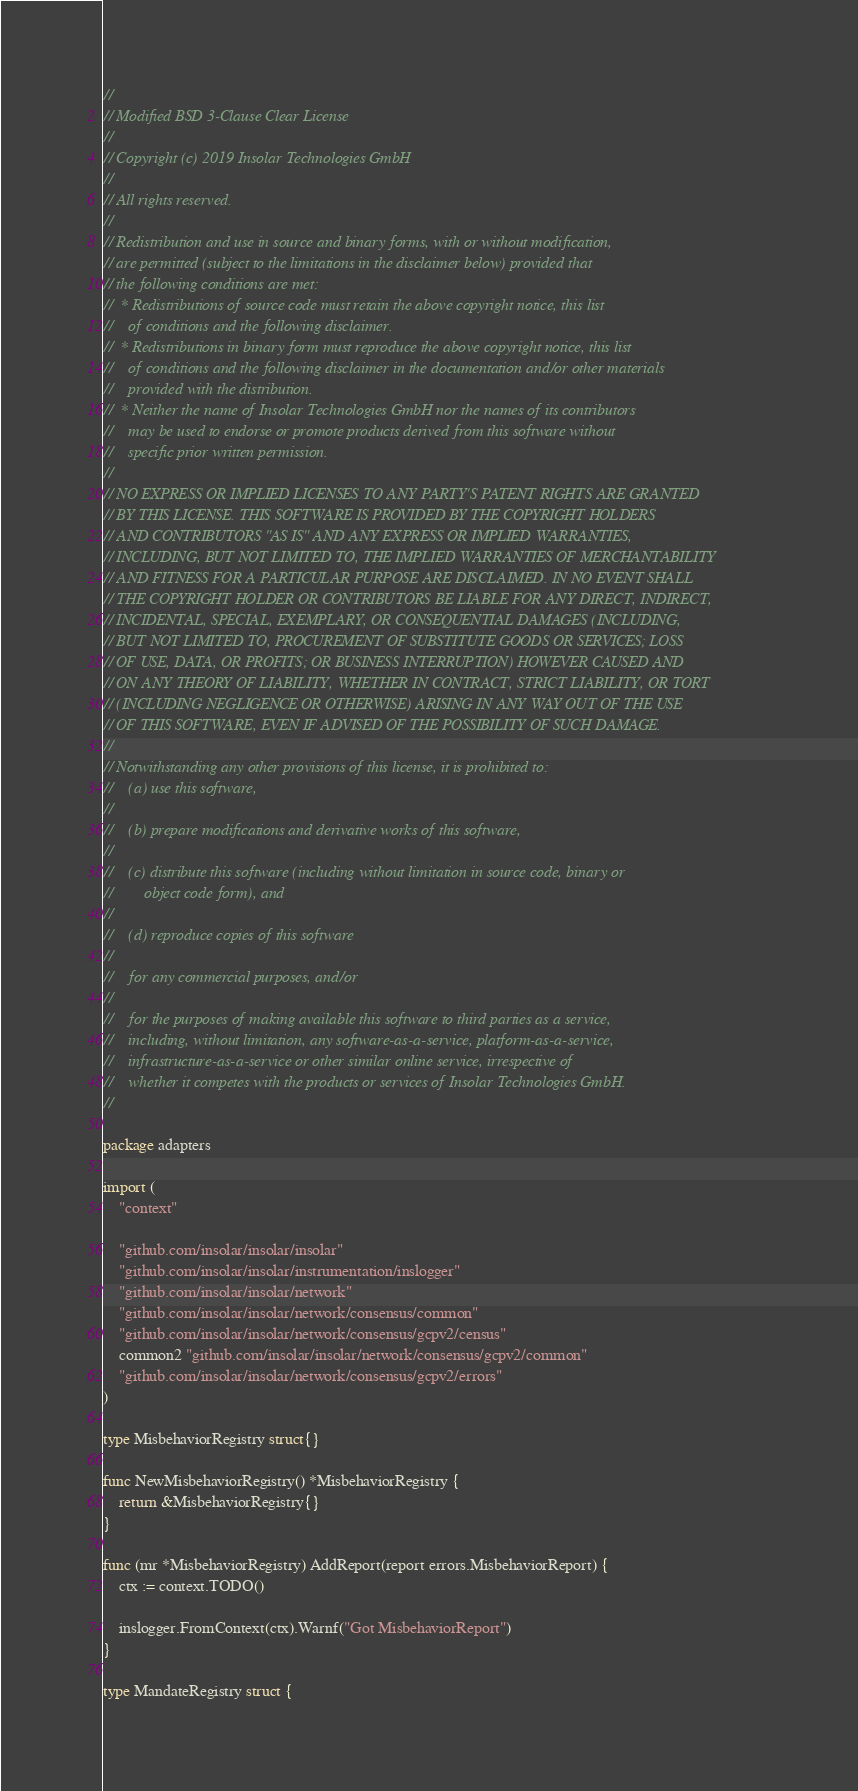Convert code to text. <code><loc_0><loc_0><loc_500><loc_500><_Go_>//
// Modified BSD 3-Clause Clear License
//
// Copyright (c) 2019 Insolar Technologies GmbH
//
// All rights reserved.
//
// Redistribution and use in source and binary forms, with or without modification,
// are permitted (subject to the limitations in the disclaimer below) provided that
// the following conditions are met:
//  * Redistributions of source code must retain the above copyright notice, this list
//    of conditions and the following disclaimer.
//  * Redistributions in binary form must reproduce the above copyright notice, this list
//    of conditions and the following disclaimer in the documentation and/or other materials
//    provided with the distribution.
//  * Neither the name of Insolar Technologies GmbH nor the names of its contributors
//    may be used to endorse or promote products derived from this software without
//    specific prior written permission.
//
// NO EXPRESS OR IMPLIED LICENSES TO ANY PARTY'S PATENT RIGHTS ARE GRANTED
// BY THIS LICENSE. THIS SOFTWARE IS PROVIDED BY THE COPYRIGHT HOLDERS
// AND CONTRIBUTORS "AS IS" AND ANY EXPRESS OR IMPLIED WARRANTIES,
// INCLUDING, BUT NOT LIMITED TO, THE IMPLIED WARRANTIES OF MERCHANTABILITY
// AND FITNESS FOR A PARTICULAR PURPOSE ARE DISCLAIMED. IN NO EVENT SHALL
// THE COPYRIGHT HOLDER OR CONTRIBUTORS BE LIABLE FOR ANY DIRECT, INDIRECT,
// INCIDENTAL, SPECIAL, EXEMPLARY, OR CONSEQUENTIAL DAMAGES (INCLUDING,
// BUT NOT LIMITED TO, PROCUREMENT OF SUBSTITUTE GOODS OR SERVICES; LOSS
// OF USE, DATA, OR PROFITS; OR BUSINESS INTERRUPTION) HOWEVER CAUSED AND
// ON ANY THEORY OF LIABILITY, WHETHER IN CONTRACT, STRICT LIABILITY, OR TORT
// (INCLUDING NEGLIGENCE OR OTHERWISE) ARISING IN ANY WAY OUT OF THE USE
// OF THIS SOFTWARE, EVEN IF ADVISED OF THE POSSIBILITY OF SUCH DAMAGE.
//
// Notwithstanding any other provisions of this license, it is prohibited to:
//    (a) use this software,
//
//    (b) prepare modifications and derivative works of this software,
//
//    (c) distribute this software (including without limitation in source code, binary or
//        object code form), and
//
//    (d) reproduce copies of this software
//
//    for any commercial purposes, and/or
//
//    for the purposes of making available this software to third parties as a service,
//    including, without limitation, any software-as-a-service, platform-as-a-service,
//    infrastructure-as-a-service or other similar online service, irrespective of
//    whether it competes with the products or services of Insolar Technologies GmbH.
//

package adapters

import (
	"context"

	"github.com/insolar/insolar/insolar"
	"github.com/insolar/insolar/instrumentation/inslogger"
	"github.com/insolar/insolar/network"
	"github.com/insolar/insolar/network/consensus/common"
	"github.com/insolar/insolar/network/consensus/gcpv2/census"
	common2 "github.com/insolar/insolar/network/consensus/gcpv2/common"
	"github.com/insolar/insolar/network/consensus/gcpv2/errors"
)

type MisbehaviorRegistry struct{}

func NewMisbehaviorRegistry() *MisbehaviorRegistry {
	return &MisbehaviorRegistry{}
}

func (mr *MisbehaviorRegistry) AddReport(report errors.MisbehaviorReport) {
	ctx := context.TODO()

	inslogger.FromContext(ctx).Warnf("Got MisbehaviorReport")
}

type MandateRegistry struct {</code> 